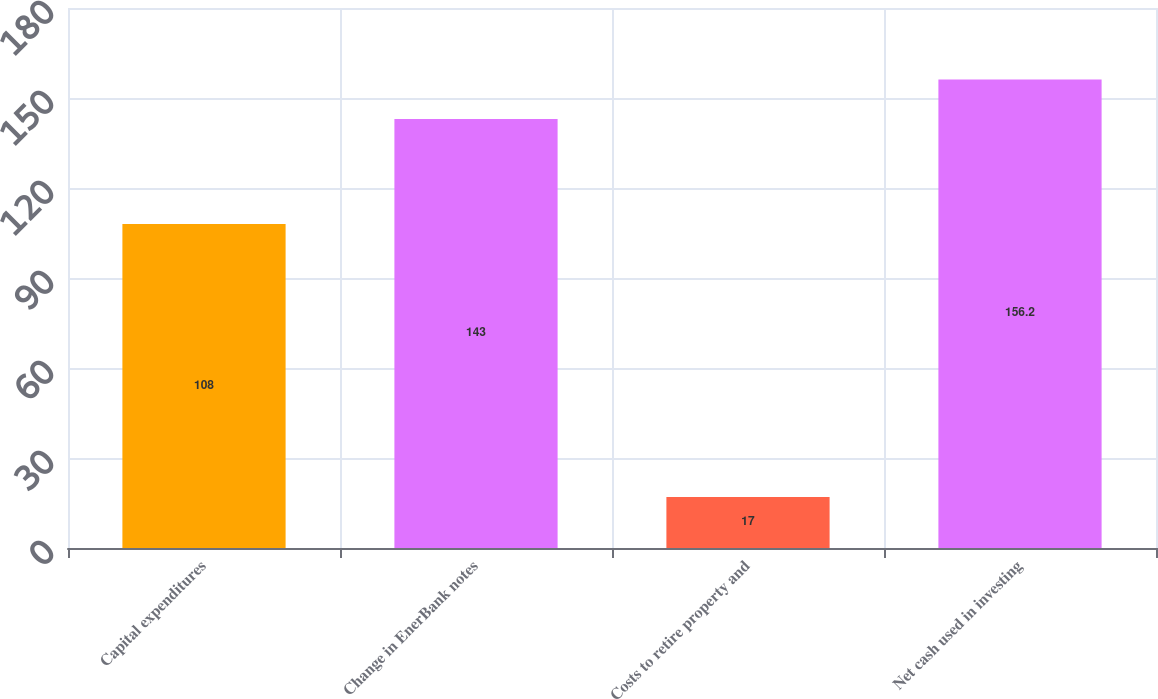Convert chart. <chart><loc_0><loc_0><loc_500><loc_500><bar_chart><fcel>Capital expenditures<fcel>Change in EnerBank notes<fcel>Costs to retire property and<fcel>Net cash used in investing<nl><fcel>108<fcel>143<fcel>17<fcel>156.2<nl></chart> 